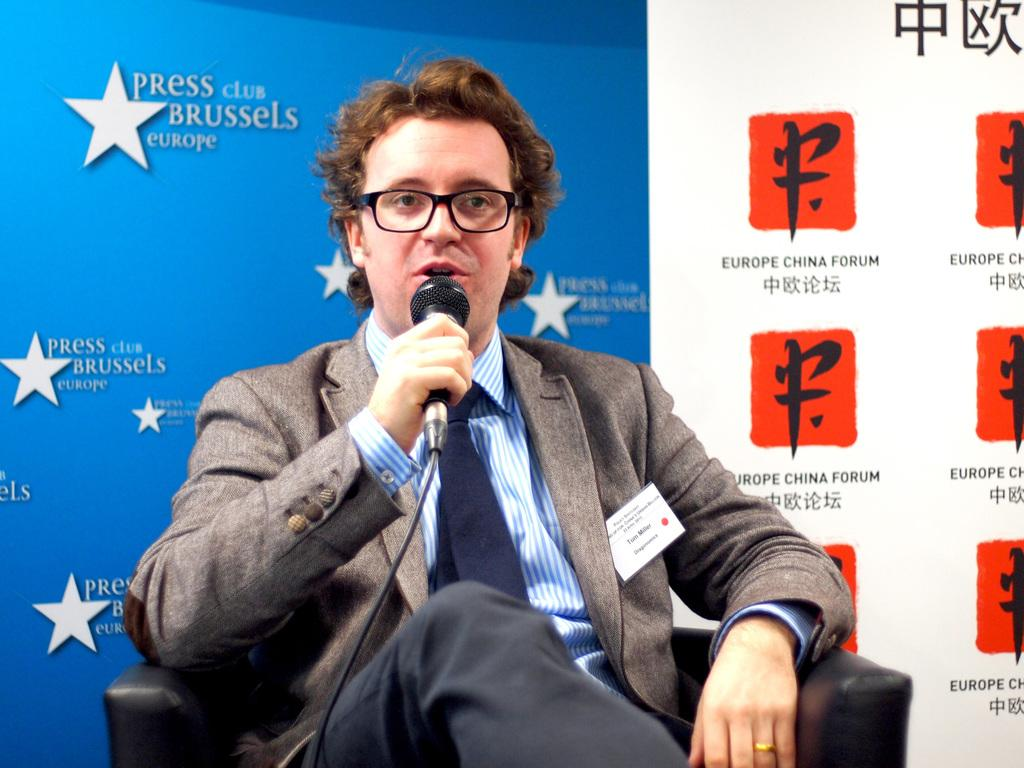What is present in the image? There is a man in the image. What is the man doing in the image? The man is sitting on a chair. What object is the man holding in his hand? The man is holding a microphone in his hand. What type of instrument is the man playing in the image? There is no instrument present in the image; the man is holding a microphone. Can you tell me how many suns are visible in the image? There is no sun present in the image. 